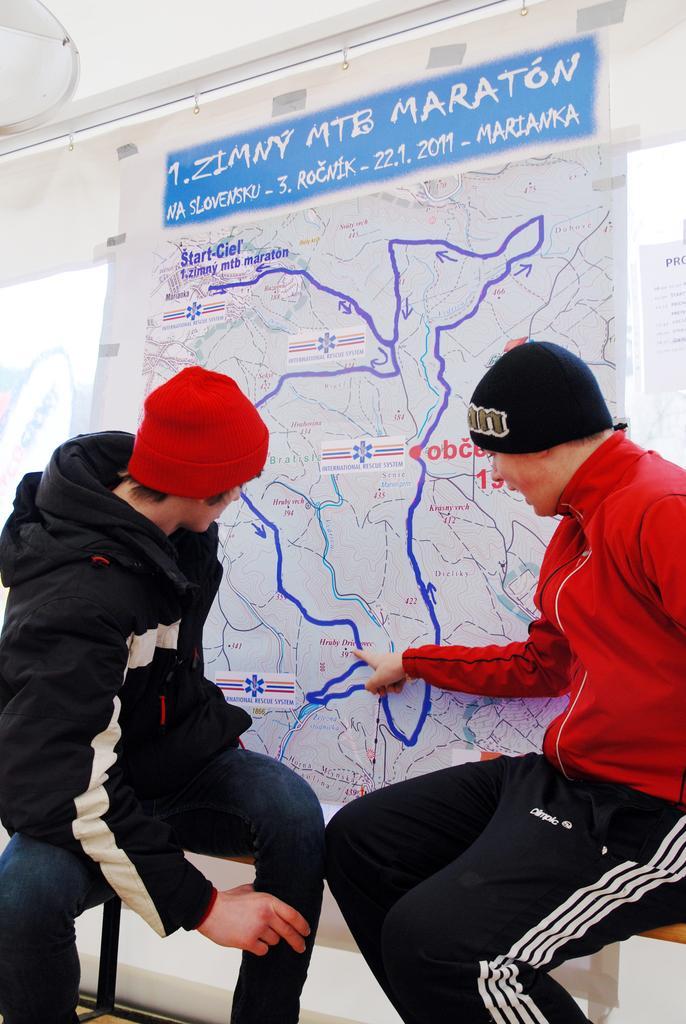Could you give a brief overview of what you see in this image? In this picture there are two boys wearing a black and red color hoodies sitting on the bench and looking to the map banner. Behind there is a glass wall. 